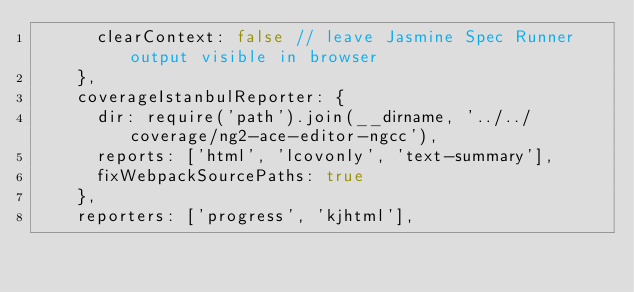<code> <loc_0><loc_0><loc_500><loc_500><_JavaScript_>      clearContext: false // leave Jasmine Spec Runner output visible in browser
    },
    coverageIstanbulReporter: {
      dir: require('path').join(__dirname, '../../coverage/ng2-ace-editor-ngcc'),
      reports: ['html', 'lcovonly', 'text-summary'],
      fixWebpackSourcePaths: true
    },
    reporters: ['progress', 'kjhtml'],</code> 